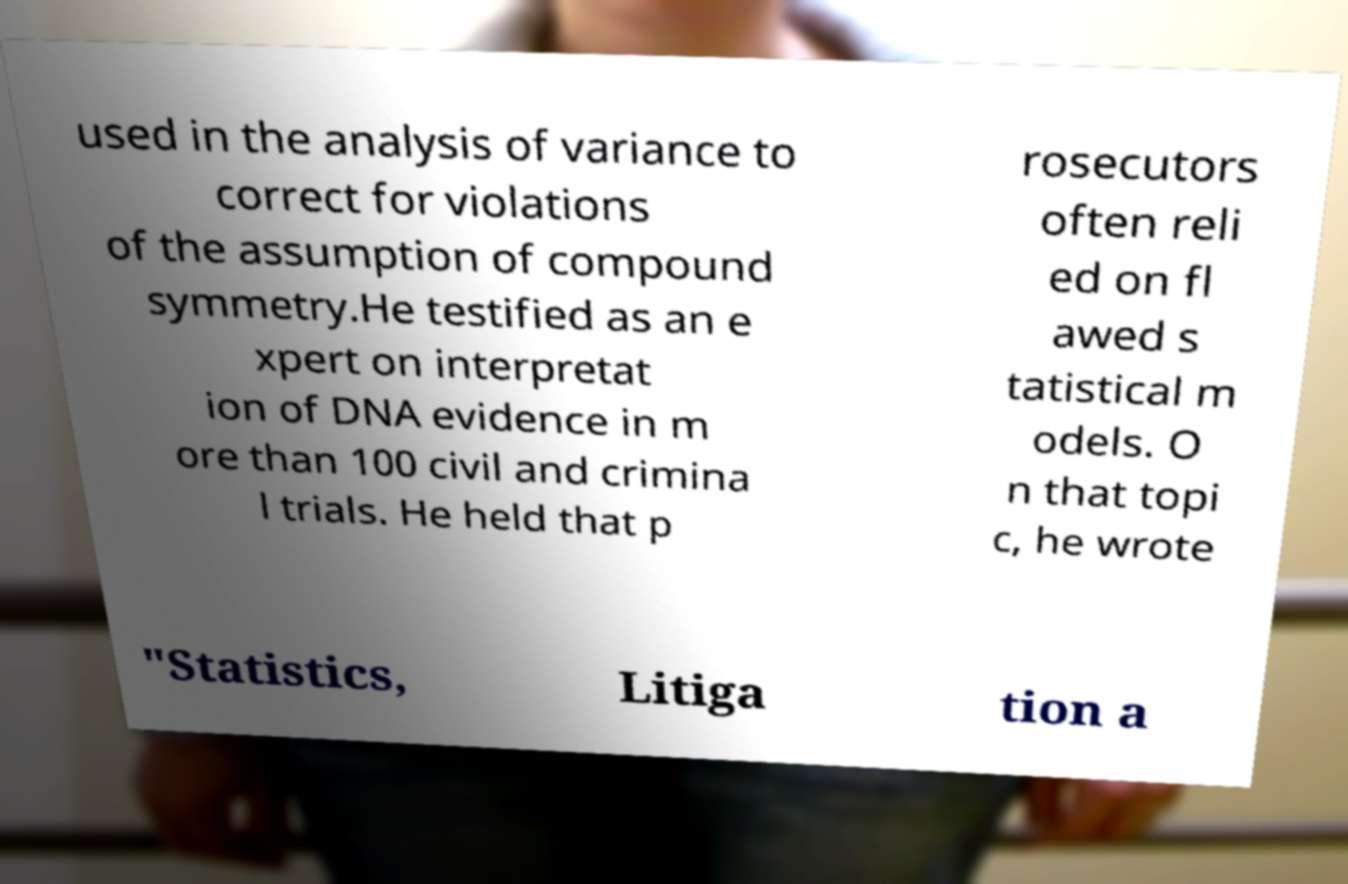For documentation purposes, I need the text within this image transcribed. Could you provide that? used in the analysis of variance to correct for violations of the assumption of compound symmetry.He testified as an e xpert on interpretat ion of DNA evidence in m ore than 100 civil and crimina l trials. He held that p rosecutors often reli ed on fl awed s tatistical m odels. O n that topi c, he wrote "Statistics, Litiga tion a 